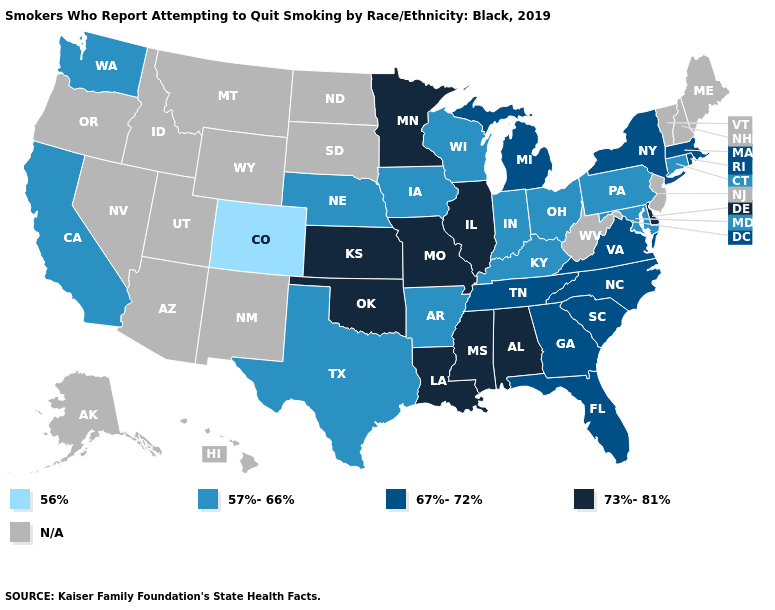What is the highest value in the West ?
Answer briefly. 57%-66%. Name the states that have a value in the range N/A?
Concise answer only. Alaska, Arizona, Hawaii, Idaho, Maine, Montana, Nevada, New Hampshire, New Jersey, New Mexico, North Dakota, Oregon, South Dakota, Utah, Vermont, West Virginia, Wyoming. Does Colorado have the highest value in the USA?
Answer briefly. No. Among the states that border Arizona , which have the lowest value?
Answer briefly. Colorado. What is the lowest value in states that border Alabama?
Short answer required. 67%-72%. Name the states that have a value in the range 57%-66%?
Quick response, please. Arkansas, California, Connecticut, Indiana, Iowa, Kentucky, Maryland, Nebraska, Ohio, Pennsylvania, Texas, Washington, Wisconsin. Among the states that border Louisiana , does Mississippi have the lowest value?
Keep it brief. No. Does Colorado have the lowest value in the USA?
Write a very short answer. Yes. Name the states that have a value in the range N/A?
Keep it brief. Alaska, Arizona, Hawaii, Idaho, Maine, Montana, Nevada, New Hampshire, New Jersey, New Mexico, North Dakota, Oregon, South Dakota, Utah, Vermont, West Virginia, Wyoming. Name the states that have a value in the range 56%?
Answer briefly. Colorado. Does the map have missing data?
Write a very short answer. Yes. What is the value of Vermont?
Be succinct. N/A. Among the states that border Texas , which have the highest value?
Write a very short answer. Louisiana, Oklahoma. How many symbols are there in the legend?
Short answer required. 5. 